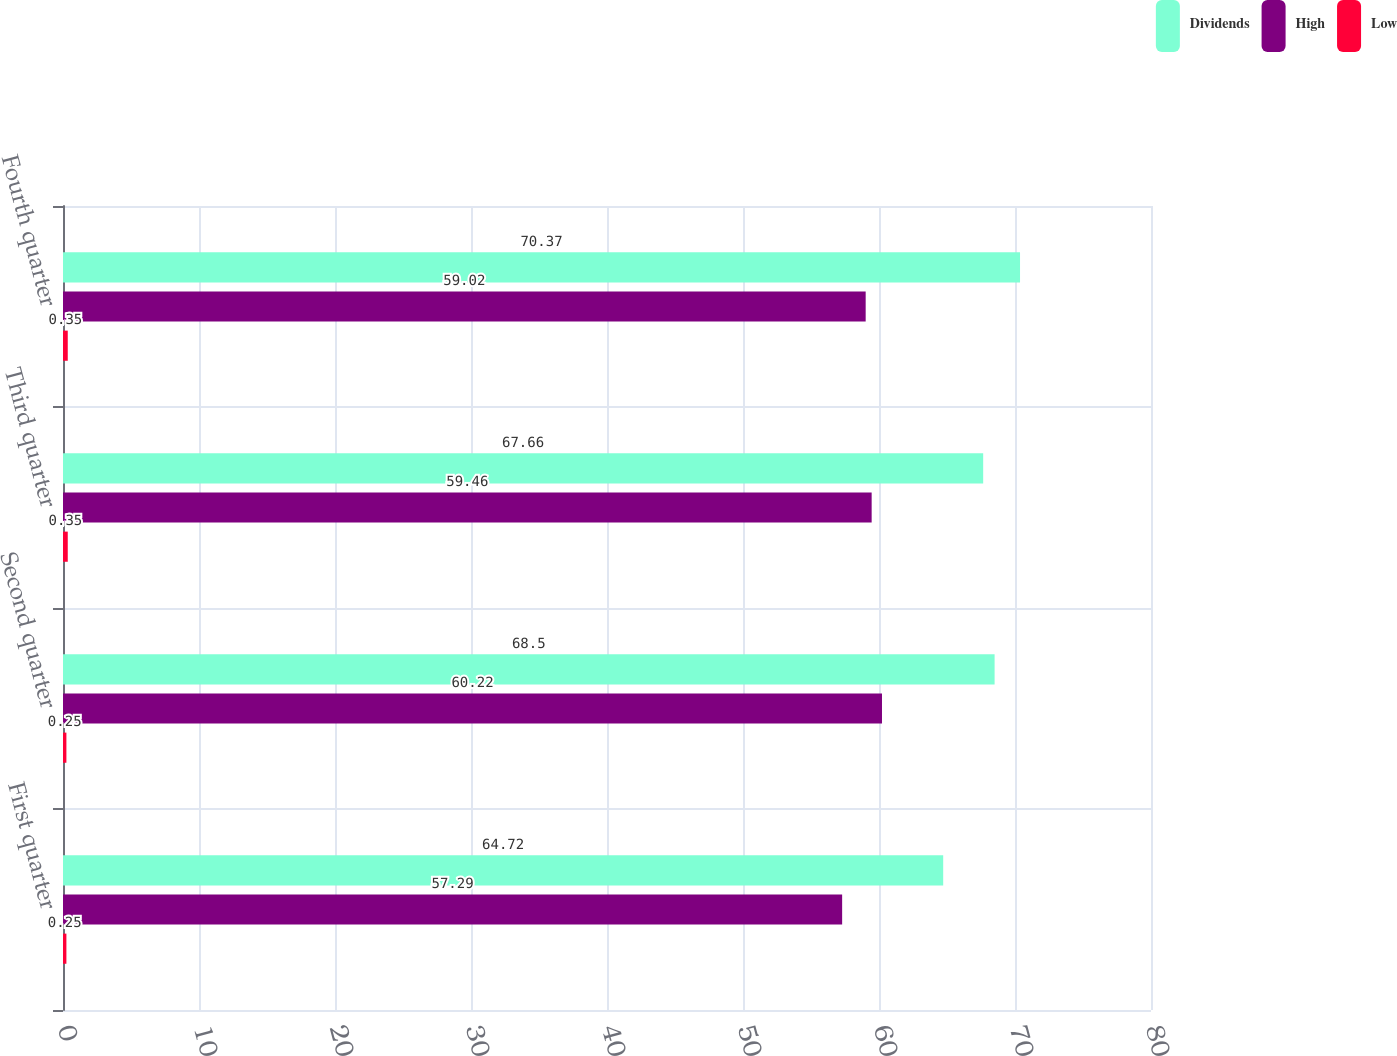Convert chart to OTSL. <chart><loc_0><loc_0><loc_500><loc_500><stacked_bar_chart><ecel><fcel>First quarter<fcel>Second quarter<fcel>Third quarter<fcel>Fourth quarter<nl><fcel>Dividends<fcel>64.72<fcel>68.5<fcel>67.66<fcel>70.37<nl><fcel>High<fcel>57.29<fcel>60.22<fcel>59.46<fcel>59.02<nl><fcel>Low<fcel>0.25<fcel>0.25<fcel>0.35<fcel>0.35<nl></chart> 